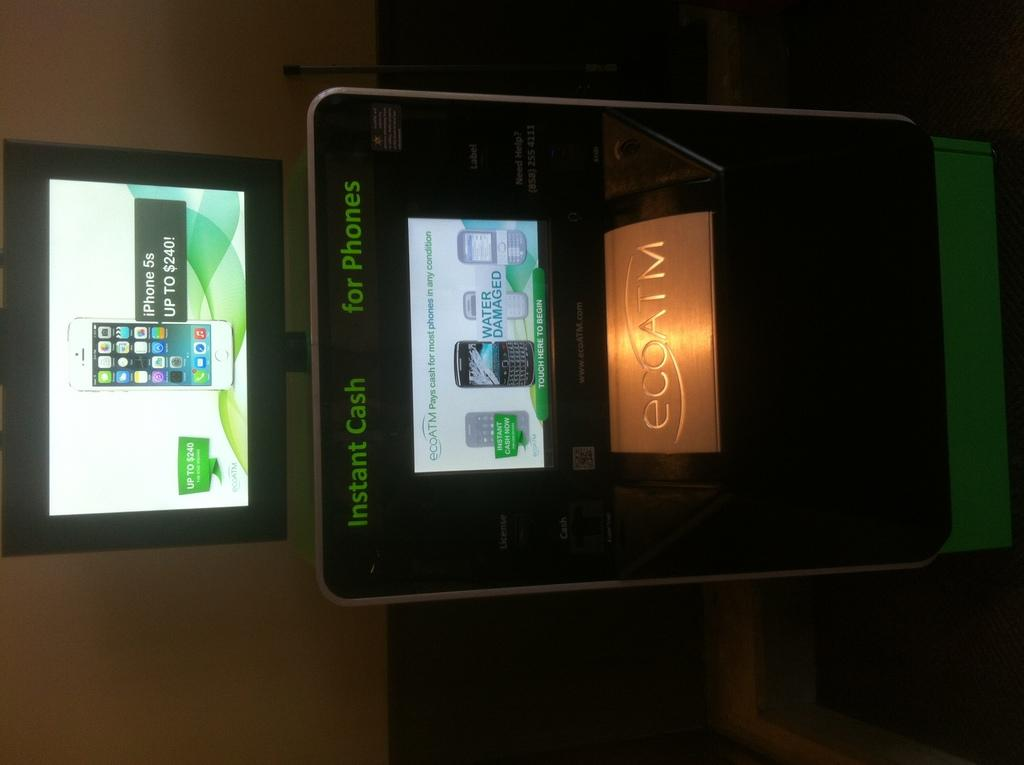<image>
Render a clear and concise summary of the photo. An Instant Cash for Phones machine sits lit up with a screen on top showing an Iphone 5S. 